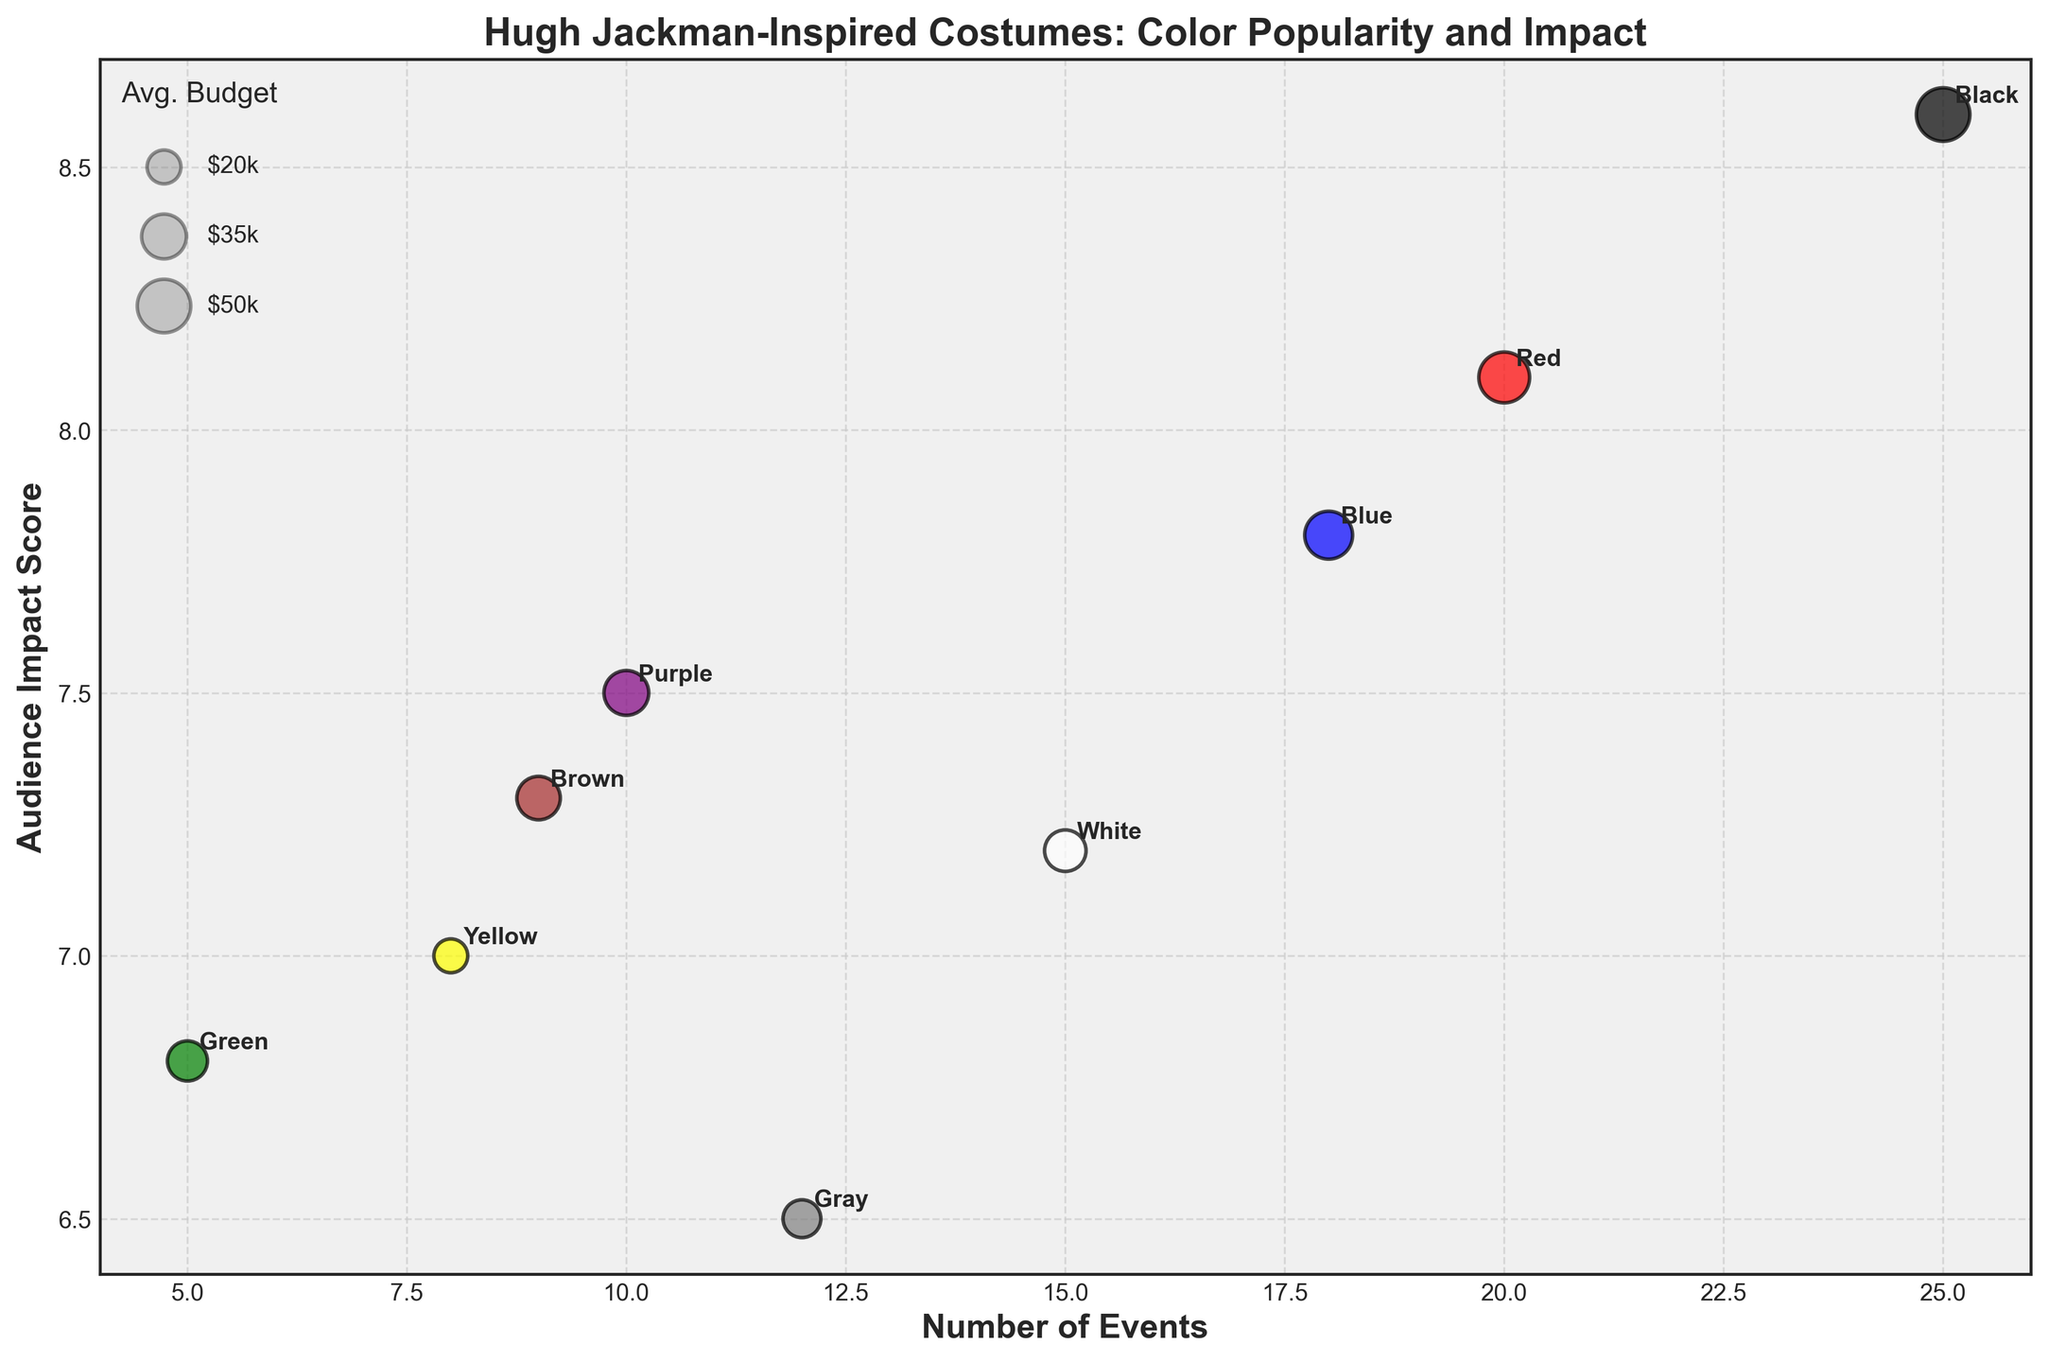What is the title of the bubble chart? The title is located at the top of the chart and summarizes what the chart is about. Here, it states, "Hugh Jackman-Inspired Costumes: Color Popularity and Impact."
Answer: Hugh Jackman-Inspired Costumes: Color Popularity and Impact How many color categories are represented in the plot? Count the number of different colors labeled on the chart. Each color name appears once.
Answer: 9 Which color is associated with the highest Audience Impact Score? Look at the y-axis (Audience Impact Score) and find the color corresponding to the highest point.
Answer: Black What does the size of the bubbles represent? The legend for bubble size indicates that the size of the bubbles corresponds to the 'Average Budget (Thousands USD).'
Answer: Average Budget (Thousands USD) How does the number of events relate to the audience impact score for Blue costumes? Find the bubble labeled 'Blue' and note its position in relation to the x-axis (Number of Events) and y-axis (Audience Impact Score). Blue has 18 events and an impact score of 7.8.
Answer: 18 events and 7.8 impact score Which color had the lowest number of events? Compare the positions of the bubbles along the x-axis (Number of Events) to find the smallest value. The green bubble is furthest to the left.
Answer: Green What colors have a higher average budget than Blue? Find the size of the Blue bubble on the legend and compare it to other bubbles. White (30k), Red (45k), Black (50k), Purple (35k), and Brown (33k) are larger.
Answer: Black, Red, Purple, Brown What is the combined number of events for Black and White colors? Add the Number of Events for Black and White from their respective bubbles: Black (25) + White (15) = 40.
Answer: 40 Which colors have an audience impact score greater than 7.5? Compare the y-axis positions of each bubble to determine which exceed the 7.5 mark. Black, Red, Blue, Purple, and Brown have higher scores.
Answer: Black, Red, Blue, Purple, Brown What is the average Audience Impact Score of colors with more than 10 events? Consider the Audience Impact Scores for colors with more than 10 events: Black (8.6), White (7.2), Red (8.1), Blue (7.8), Gray (6.5). Calculate the average: (8.6 + 7.2 + 8.1 + 7.8 + 6.5)/5 = 7.64.
Answer: 7.64 